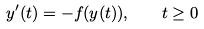<formula> <loc_0><loc_0><loc_500><loc_500>y ^ { \prime } ( t ) = - f ( y ( t ) ) , \quad t \geq 0</formula> 